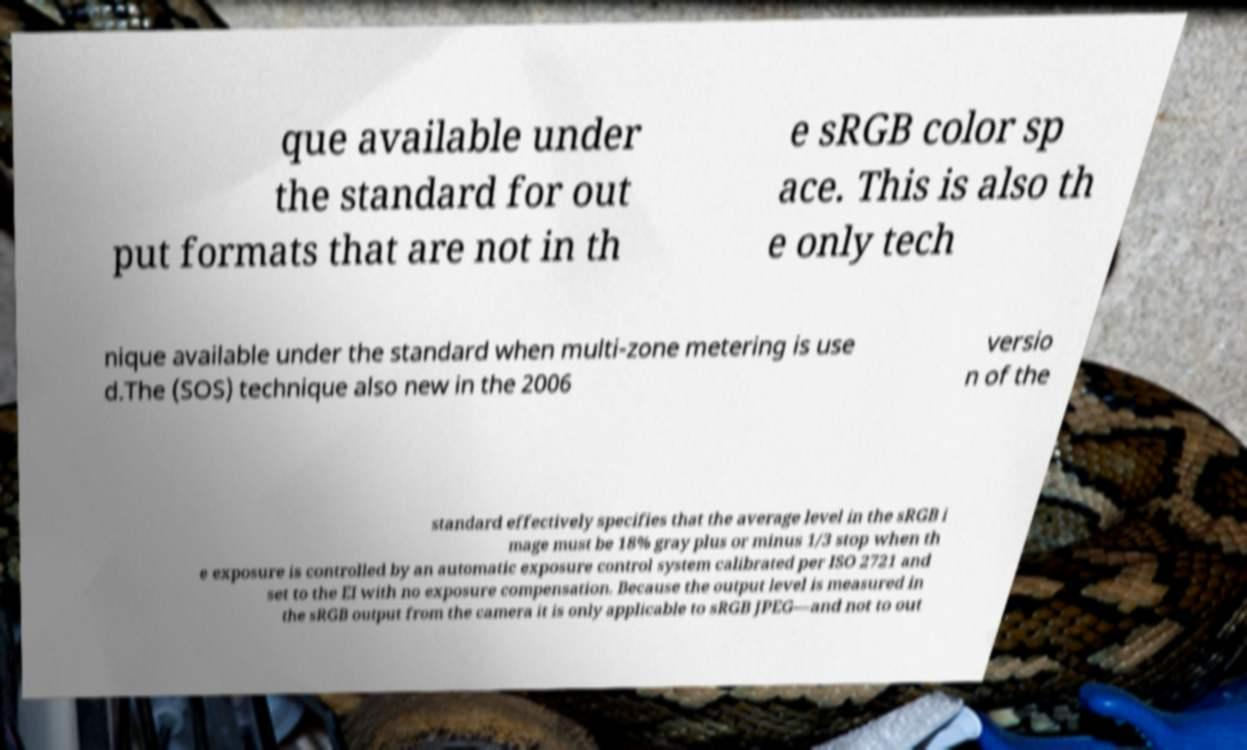I need the written content from this picture converted into text. Can you do that? que available under the standard for out put formats that are not in th e sRGB color sp ace. This is also th e only tech nique available under the standard when multi-zone metering is use d.The (SOS) technique also new in the 2006 versio n of the standard effectively specifies that the average level in the sRGB i mage must be 18% gray plus or minus 1/3 stop when th e exposure is controlled by an automatic exposure control system calibrated per ISO 2721 and set to the EI with no exposure compensation. Because the output level is measured in the sRGB output from the camera it is only applicable to sRGB JPEG—and not to out 